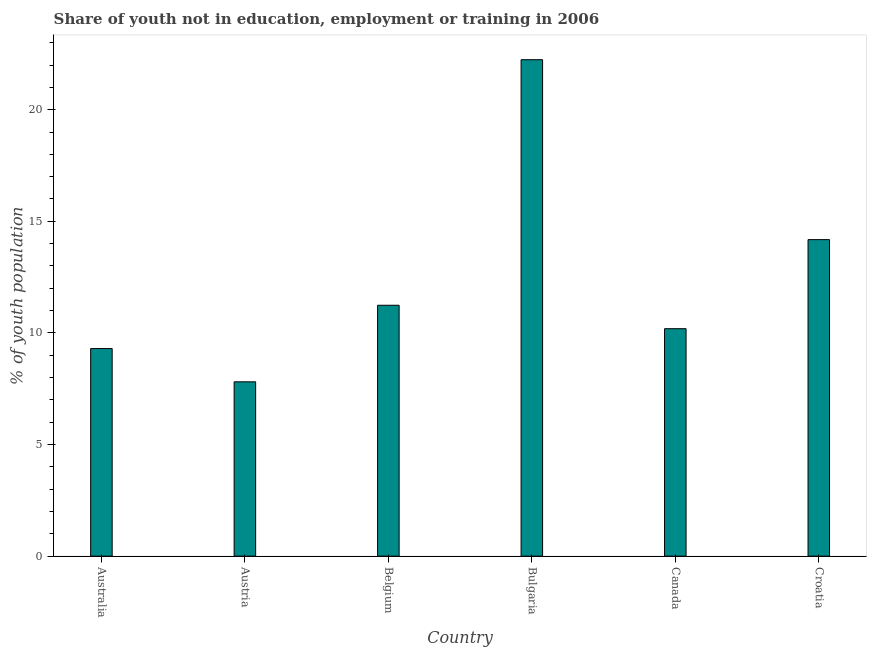Does the graph contain any zero values?
Offer a terse response. No. What is the title of the graph?
Offer a very short reply. Share of youth not in education, employment or training in 2006. What is the label or title of the Y-axis?
Give a very brief answer. % of youth population. What is the unemployed youth population in Croatia?
Your answer should be compact. 14.18. Across all countries, what is the maximum unemployed youth population?
Offer a terse response. 22.24. Across all countries, what is the minimum unemployed youth population?
Your answer should be very brief. 7.81. What is the sum of the unemployed youth population?
Offer a very short reply. 74.96. What is the difference between the unemployed youth population in Bulgaria and Croatia?
Provide a short and direct response. 8.06. What is the average unemployed youth population per country?
Offer a terse response. 12.49. What is the median unemployed youth population?
Your answer should be very brief. 10.71. What is the ratio of the unemployed youth population in Belgium to that in Bulgaria?
Your answer should be compact. 0.51. Is the unemployed youth population in Austria less than that in Belgium?
Your answer should be very brief. Yes. Is the difference between the unemployed youth population in Austria and Belgium greater than the difference between any two countries?
Your response must be concise. No. What is the difference between the highest and the second highest unemployed youth population?
Give a very brief answer. 8.06. What is the difference between the highest and the lowest unemployed youth population?
Make the answer very short. 14.43. What is the % of youth population in Australia?
Ensure brevity in your answer.  9.3. What is the % of youth population in Austria?
Your response must be concise. 7.81. What is the % of youth population of Belgium?
Provide a short and direct response. 11.24. What is the % of youth population of Bulgaria?
Your answer should be very brief. 22.24. What is the % of youth population in Canada?
Provide a short and direct response. 10.19. What is the % of youth population in Croatia?
Keep it short and to the point. 14.18. What is the difference between the % of youth population in Australia and Austria?
Ensure brevity in your answer.  1.49. What is the difference between the % of youth population in Australia and Belgium?
Give a very brief answer. -1.94. What is the difference between the % of youth population in Australia and Bulgaria?
Provide a short and direct response. -12.94. What is the difference between the % of youth population in Australia and Canada?
Offer a very short reply. -0.89. What is the difference between the % of youth population in Australia and Croatia?
Ensure brevity in your answer.  -4.88. What is the difference between the % of youth population in Austria and Belgium?
Make the answer very short. -3.43. What is the difference between the % of youth population in Austria and Bulgaria?
Keep it short and to the point. -14.43. What is the difference between the % of youth population in Austria and Canada?
Your response must be concise. -2.38. What is the difference between the % of youth population in Austria and Croatia?
Your answer should be very brief. -6.37. What is the difference between the % of youth population in Belgium and Canada?
Offer a terse response. 1.05. What is the difference between the % of youth population in Belgium and Croatia?
Keep it short and to the point. -2.94. What is the difference between the % of youth population in Bulgaria and Canada?
Your answer should be very brief. 12.05. What is the difference between the % of youth population in Bulgaria and Croatia?
Offer a very short reply. 8.06. What is the difference between the % of youth population in Canada and Croatia?
Provide a short and direct response. -3.99. What is the ratio of the % of youth population in Australia to that in Austria?
Offer a very short reply. 1.19. What is the ratio of the % of youth population in Australia to that in Belgium?
Provide a short and direct response. 0.83. What is the ratio of the % of youth population in Australia to that in Bulgaria?
Make the answer very short. 0.42. What is the ratio of the % of youth population in Australia to that in Canada?
Make the answer very short. 0.91. What is the ratio of the % of youth population in Australia to that in Croatia?
Your answer should be compact. 0.66. What is the ratio of the % of youth population in Austria to that in Belgium?
Offer a very short reply. 0.69. What is the ratio of the % of youth population in Austria to that in Bulgaria?
Make the answer very short. 0.35. What is the ratio of the % of youth population in Austria to that in Canada?
Ensure brevity in your answer.  0.77. What is the ratio of the % of youth population in Austria to that in Croatia?
Offer a terse response. 0.55. What is the ratio of the % of youth population in Belgium to that in Bulgaria?
Keep it short and to the point. 0.51. What is the ratio of the % of youth population in Belgium to that in Canada?
Your response must be concise. 1.1. What is the ratio of the % of youth population in Belgium to that in Croatia?
Offer a terse response. 0.79. What is the ratio of the % of youth population in Bulgaria to that in Canada?
Keep it short and to the point. 2.18. What is the ratio of the % of youth population in Bulgaria to that in Croatia?
Give a very brief answer. 1.57. What is the ratio of the % of youth population in Canada to that in Croatia?
Provide a short and direct response. 0.72. 